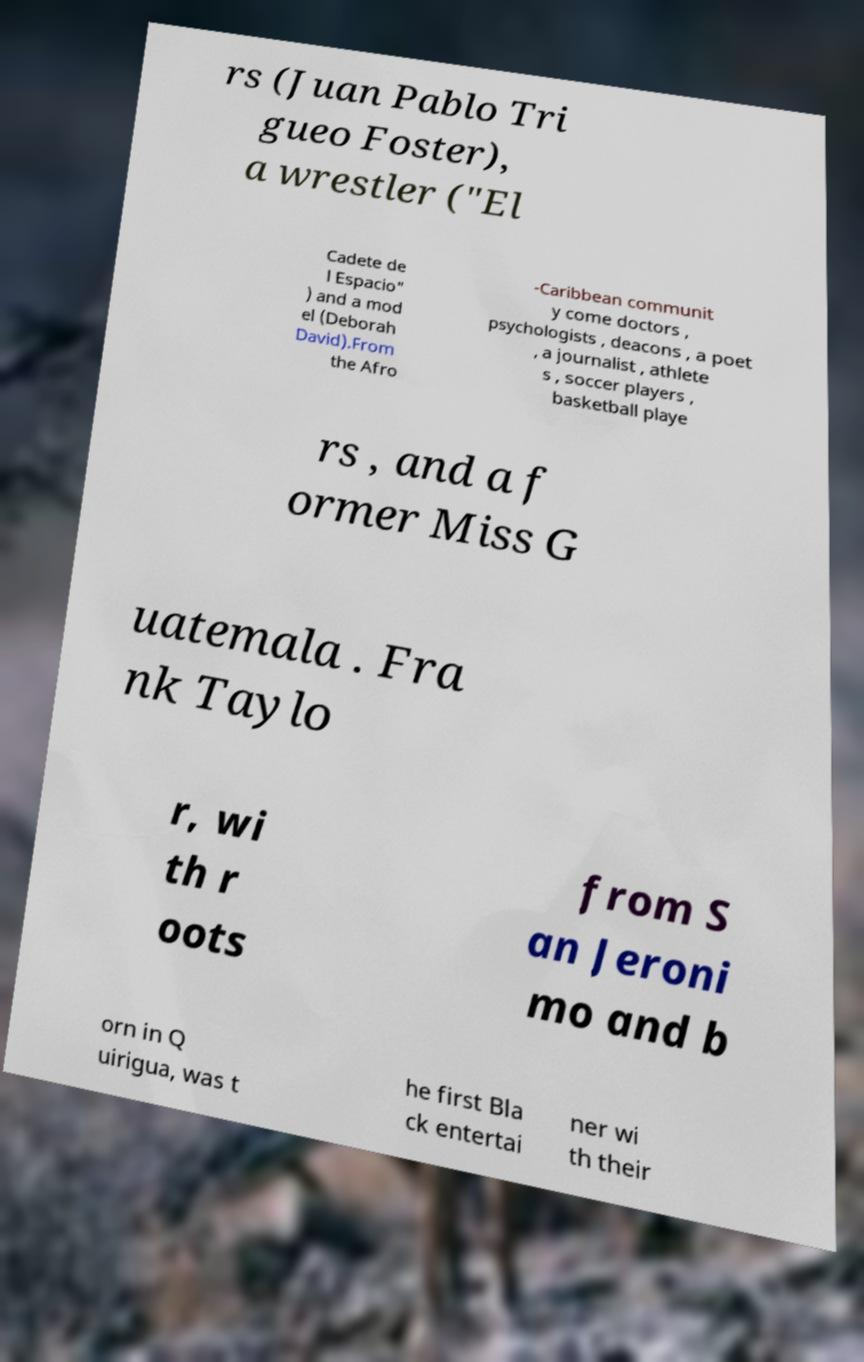Please read and relay the text visible in this image. What does it say? rs (Juan Pablo Tri gueo Foster), a wrestler ("El Cadete de l Espacio" ) and a mod el (Deborah David).From the Afro -Caribbean communit y come doctors , psychologists , deacons , a poet , a journalist , athlete s , soccer players , basketball playe rs , and a f ormer Miss G uatemala . Fra nk Taylo r, wi th r oots from S an Jeroni mo and b orn in Q uirigua, was t he first Bla ck entertai ner wi th their 